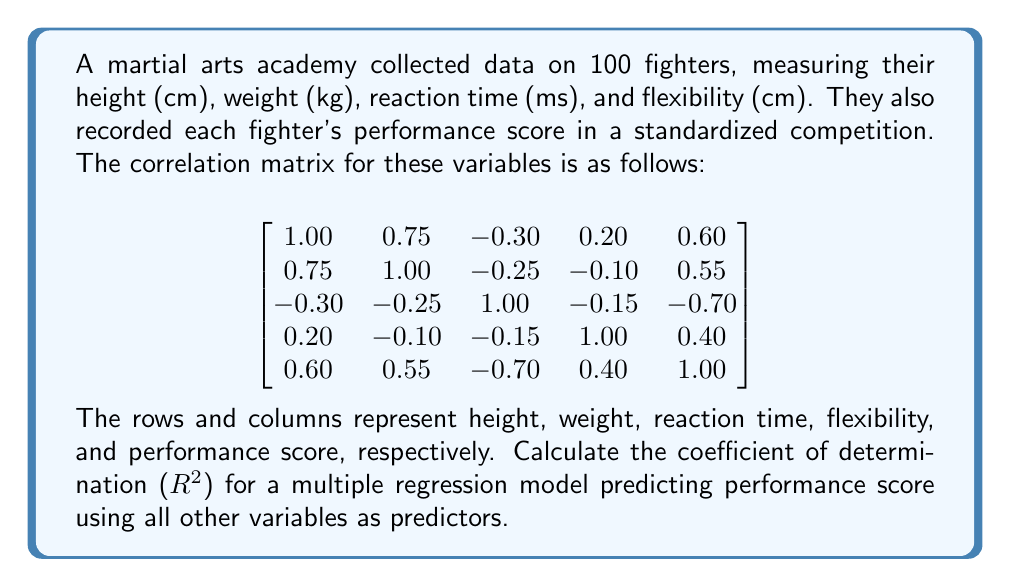Could you help me with this problem? To calculate the coefficient of determination ($R^2$) for a multiple regression model using all variables to predict the performance score, we'll follow these steps:

1) In a multiple regression model, $R^2$ can be calculated using the correlation matrix. It's equal to the squared multiple correlation coefficient.

2) The formula for $R^2$ in this case is:

   $$R^2 = 1 - \frac{1}{R_{yy}}$$

   Where $R_{yy}$ is the element in the last row and last column of the inverse of the correlation matrix.

3) First, we need to separate the correlation matrix into submatrices:

   $$R_{xx} = \begin{bmatrix}
   1.00 & 0.75 & -0.30 & 0.20 \\
   0.75 & 1.00 & -0.25 & -0.10 \\
   -0.30 & -0.25 & 1.00 & -0.15 \\
   0.20 & -0.10 & -0.15 & 1.00
   \end{bmatrix}$$

   $$R_{xy} = \begin{bmatrix}
   0.60 \\
   0.55 \\
   -0.70 \\
   0.40
   \end{bmatrix}$$

4) Then, we calculate:

   $$R_{yy} = \frac{1}{1 - R_{xy}^T R_{xx}^{-1} R_{xy}}$$

5) Using a calculator or computer program to perform the matrix operations:

   $$R_{xy}^T R_{xx}^{-1} R_{xy} \approx 0.7225$$

6) Therefore:

   $$R_{yy} = \frac{1}{1 - 0.7225} \approx 3.6036$$

7) Finally, we can calculate $R^2$:

   $$R^2 = 1 - \frac{1}{R_{yy}} = 1 - \frac{1}{3.6036} \approx 0.7225$$
Answer: $R^2 \approx 0.7225$ or $72.25\%$ 